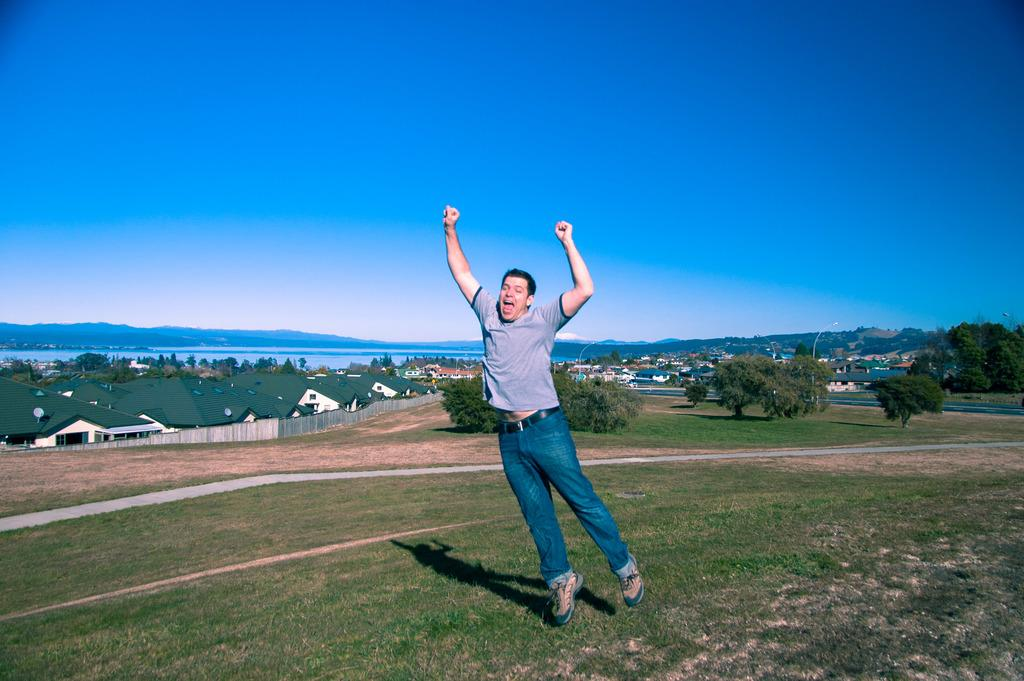What is the man in the image doing? The man is jumping in the image. What type of structures can be seen in the background? There are buildings visible in the image. What type of vegetation is present in the image? There are trees in the image. What natural element is visible in the image? There is water visible in the image. What type of ground surface is present in the image? There is grass on the ground in the image. What color is the sky in the image? The sky is blue in the image. What type of copper material is present in the image? There is no copper material present in the image. What season is depicted in the image? The provided facts do not specify a season, so it cannot be determined from the image. 